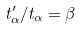Convert formula to latex. <formula><loc_0><loc_0><loc_500><loc_500>t _ { \alpha } ^ { \prime } / t _ { \alpha } = \beta</formula> 